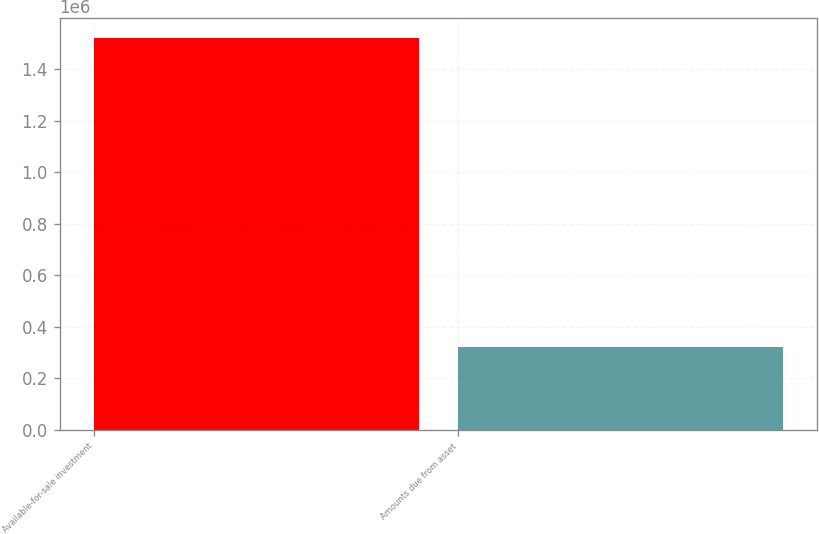Convert chart. <chart><loc_0><loc_0><loc_500><loc_500><bar_chart><fcel>Available-for-sale investment<fcel>Amounts due from asset<nl><fcel>1.52055e+06<fcel>321316<nl></chart> 